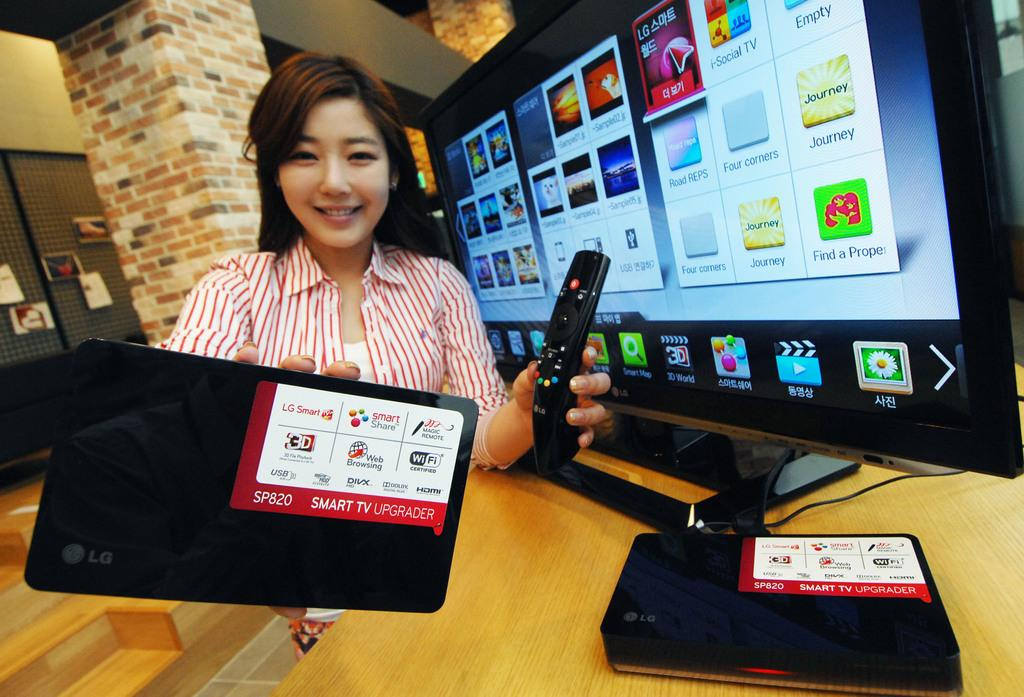Provide a one-sentence caption for the provided image. A woman holds a SP820 smart TV upgrader in her right hand. 